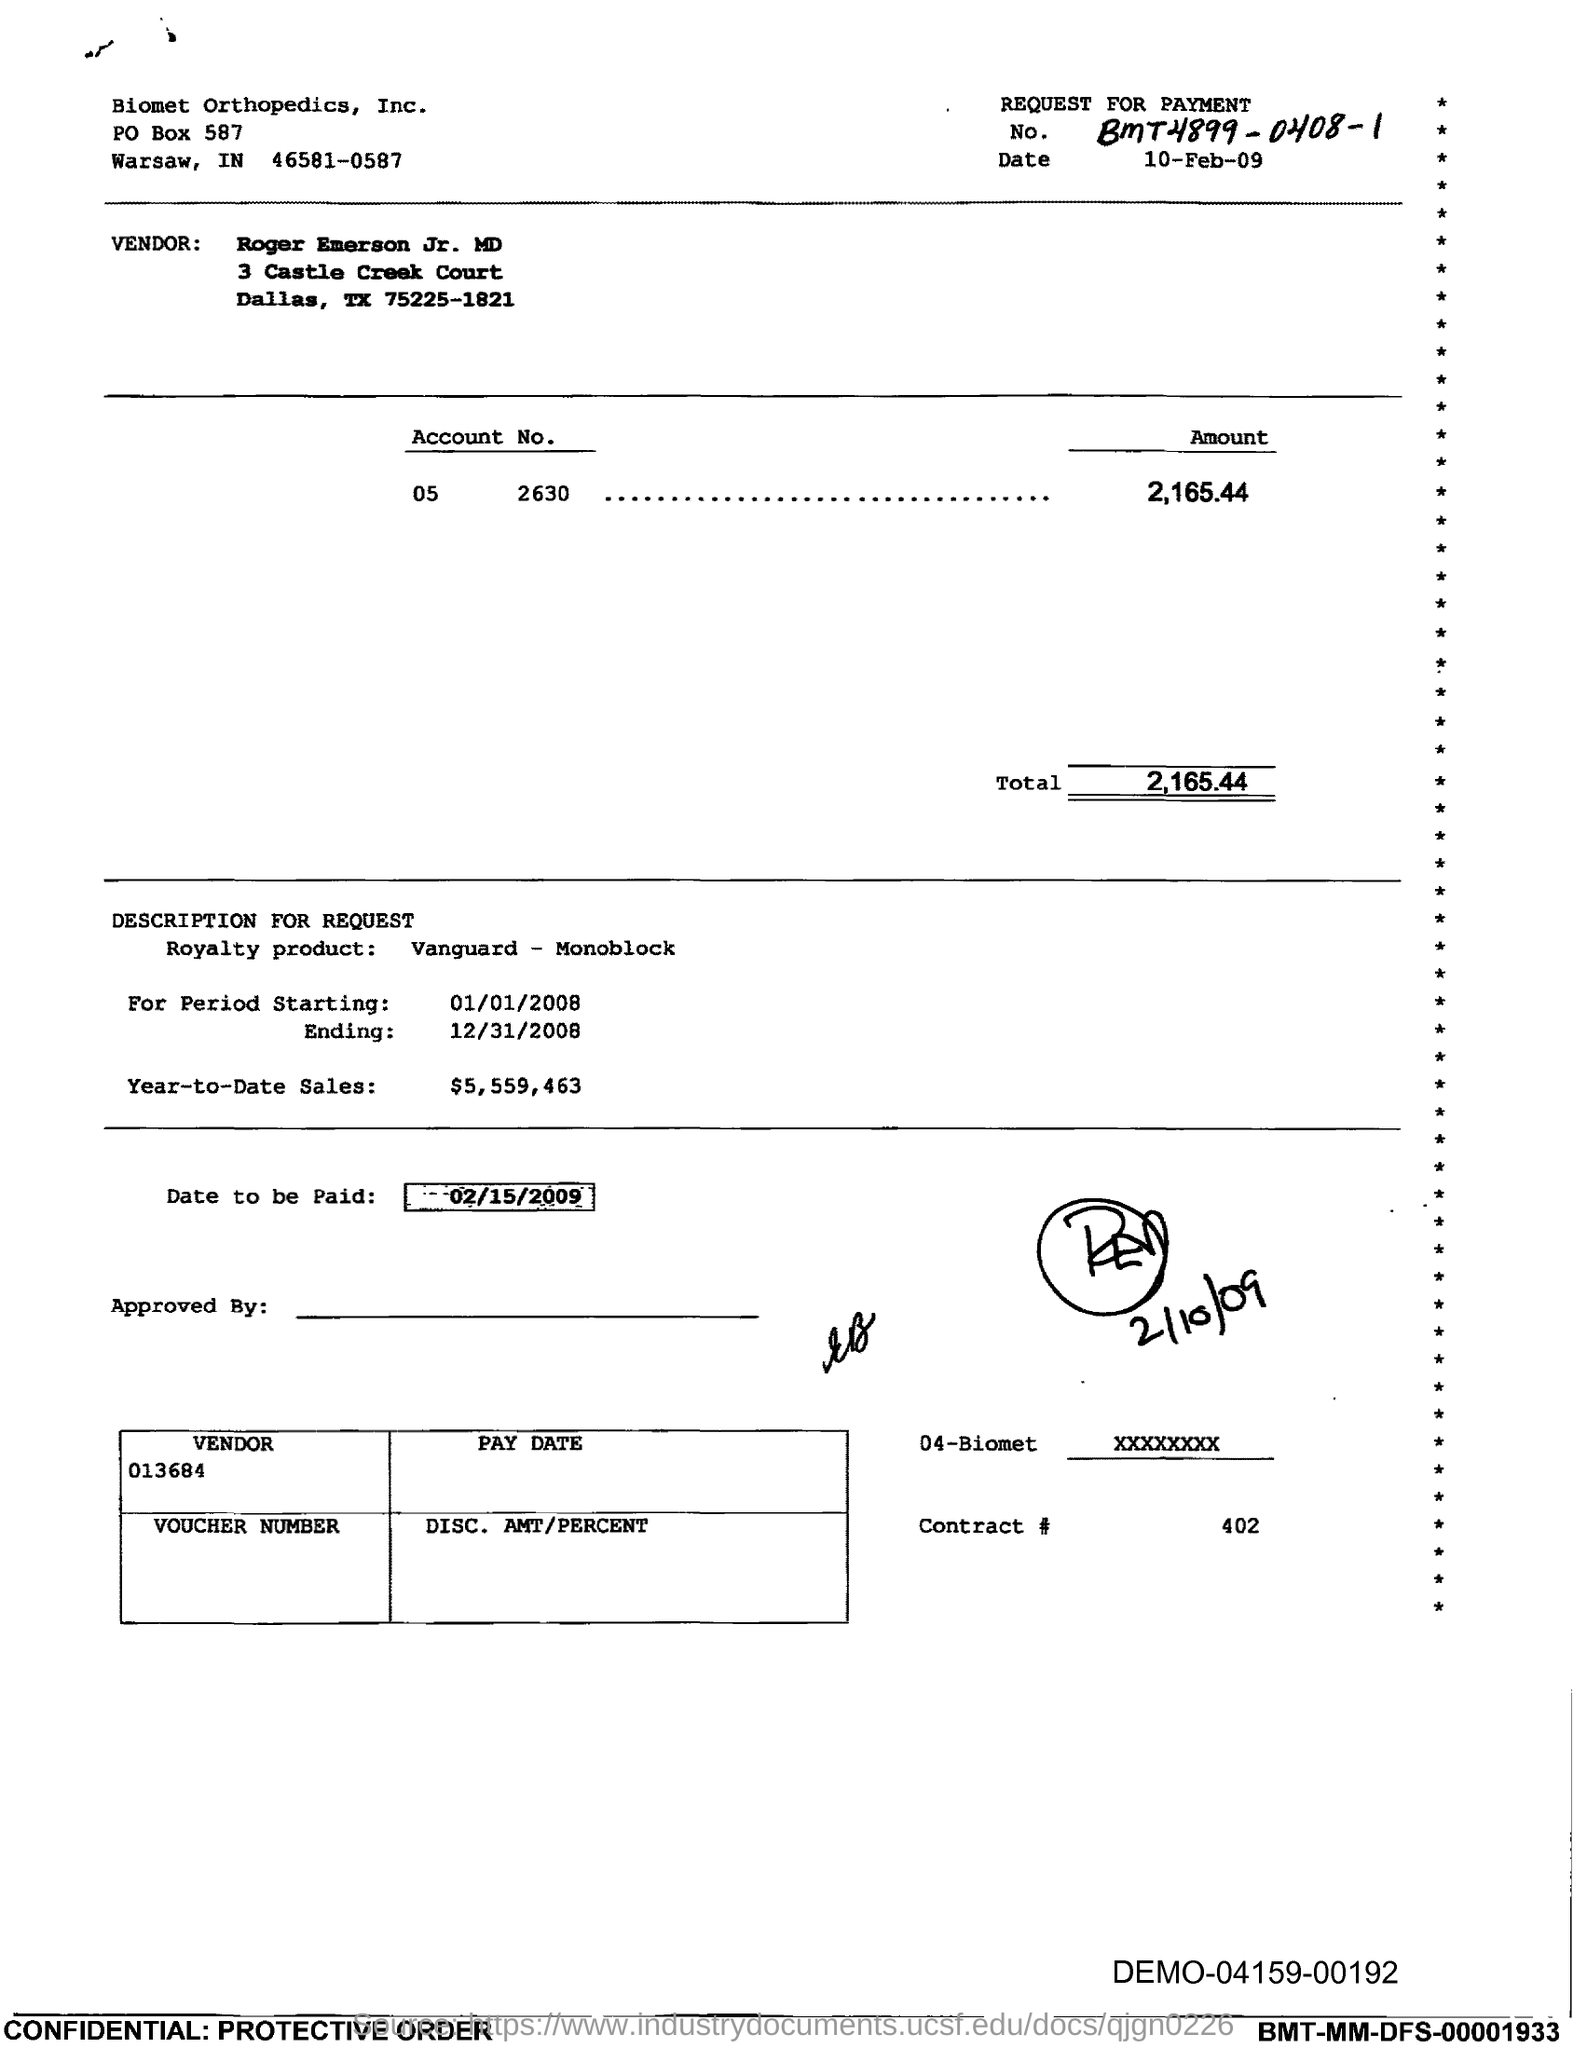Point out several critical features in this image. The ending period is December 31st, 2008. The number is BmT4899-0408-1.. The year-to-date sales as of [date] are [amount]. The date upon which payment is to be made is February 15, 2009. The date is October 10th, 2009. 